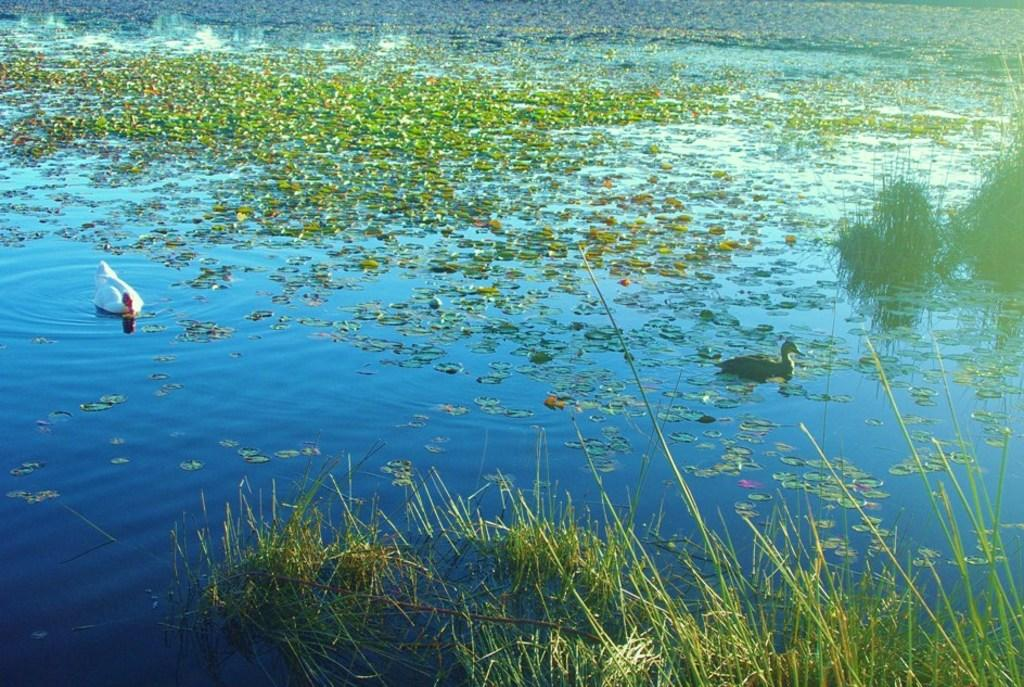What type of animals can be seen in the image? There are birds in the image. What other elements are present in the image besides the birds? There are leaves and plants in the image. Can you describe the location of the plants? The plants are on water. Where can you find the best sock deals in the image? There is no reference to a market or any sock deals in the image, so it's not possible to answer that question. 